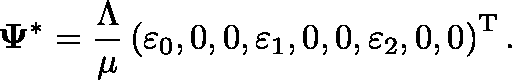Convert formula to latex. <formula><loc_0><loc_0><loc_500><loc_500>\Psi ^ { * } = \frac { \Lambda } { \mu } \left ( \varepsilon _ { 0 } , 0 , 0 , \varepsilon _ { 1 } , 0 , 0 , \varepsilon _ { 2 } , 0 , 0 \right ) ^ { T } .</formula> 